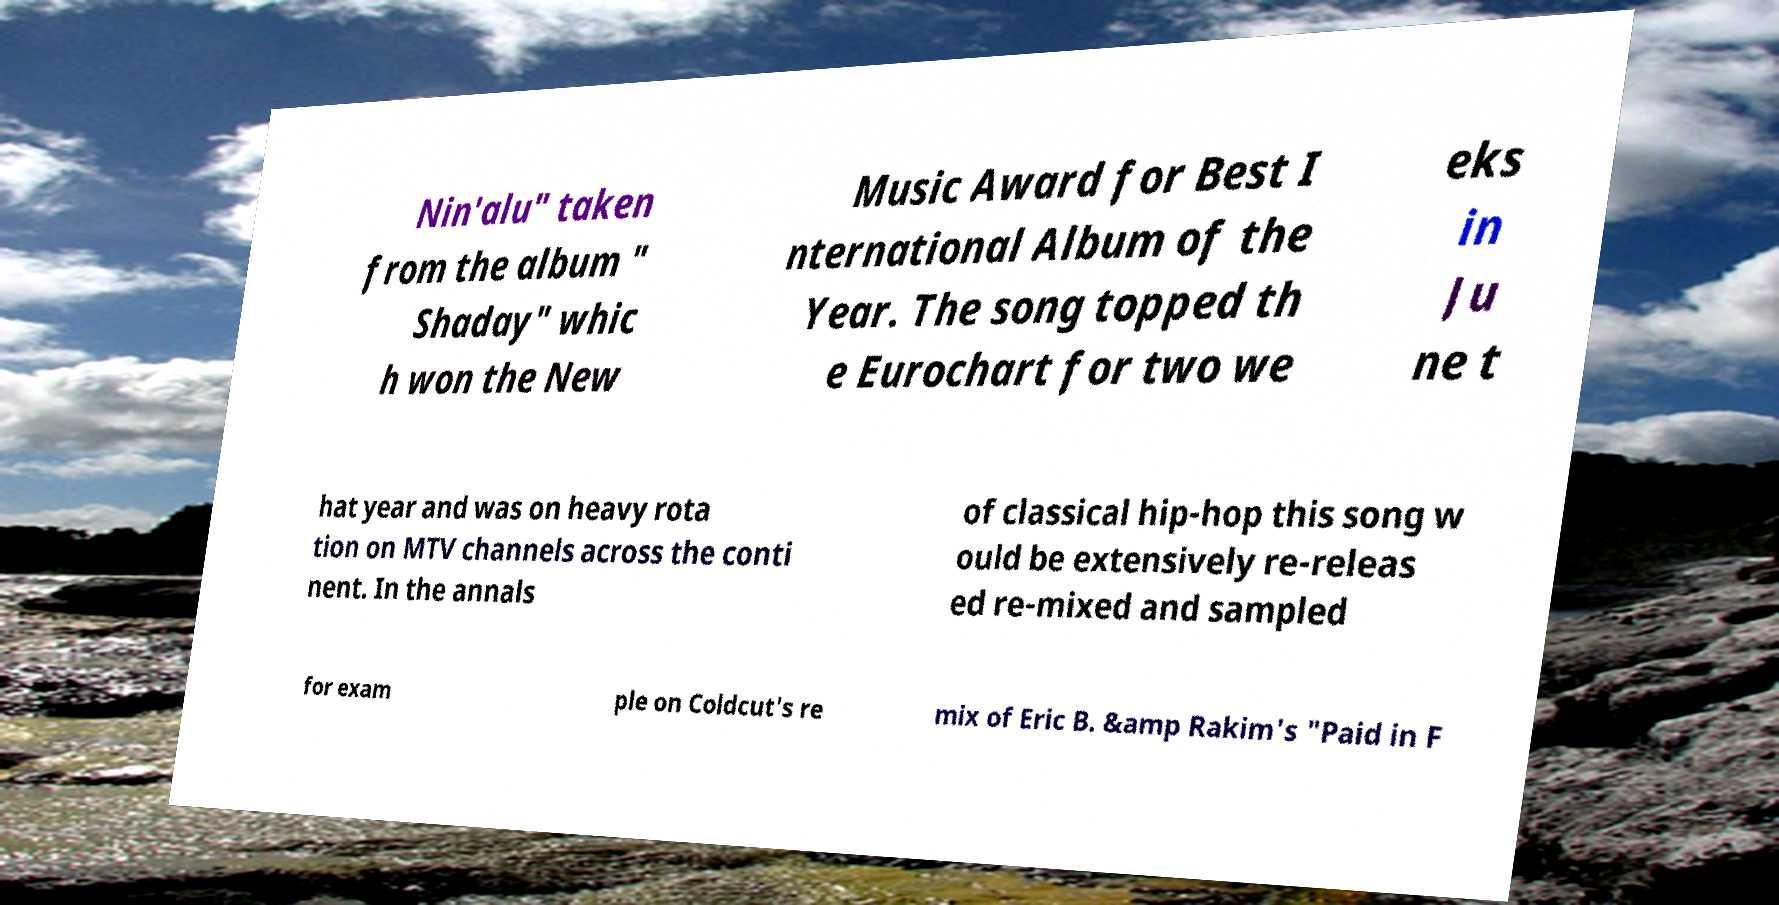Can you accurately transcribe the text from the provided image for me? Nin'alu" taken from the album " Shaday" whic h won the New Music Award for Best I nternational Album of the Year. The song topped th e Eurochart for two we eks in Ju ne t hat year and was on heavy rota tion on MTV channels across the conti nent. In the annals of classical hip-hop this song w ould be extensively re-releas ed re-mixed and sampled for exam ple on Coldcut's re mix of Eric B. &amp Rakim's "Paid in F 